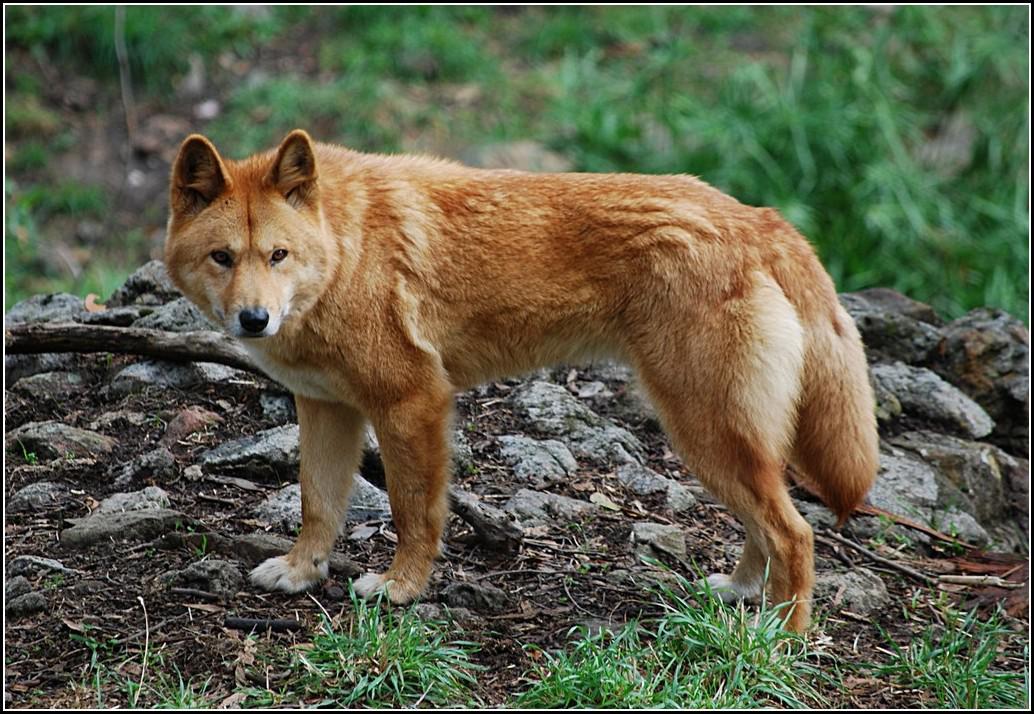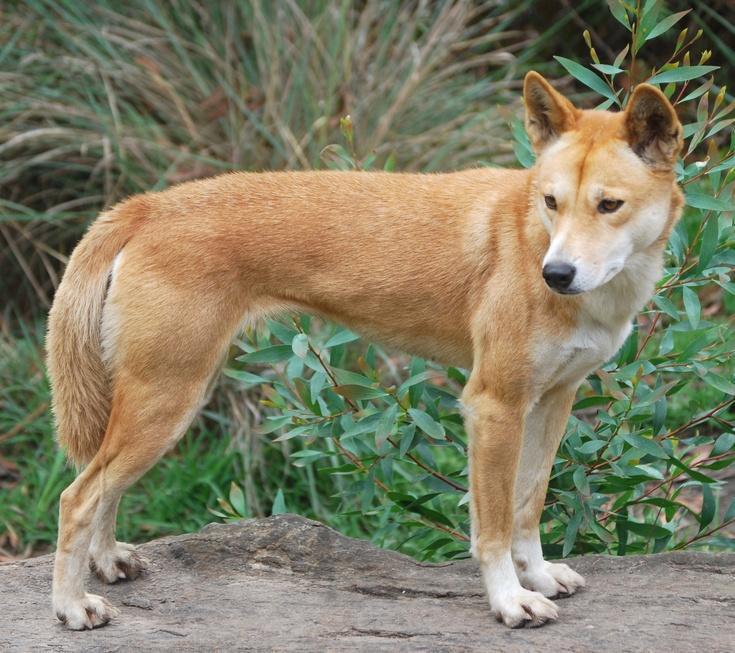The first image is the image on the left, the second image is the image on the right. For the images displayed, is the sentence "At least one dog is not wearing a collar." factually correct? Answer yes or no. Yes. 